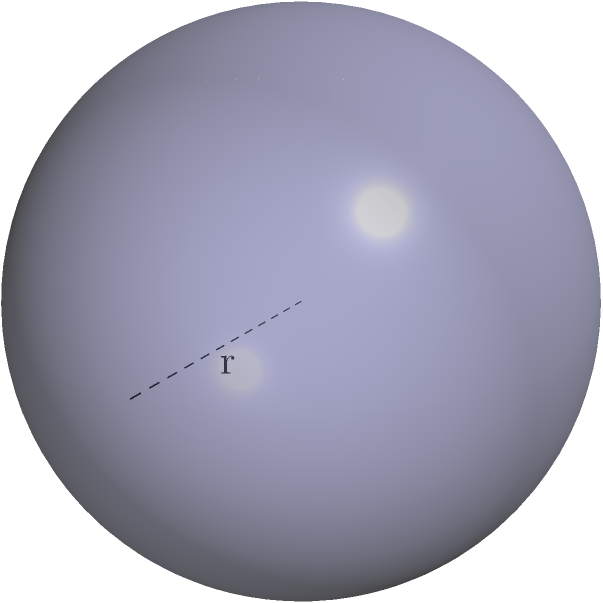In your XML integration project, you need to calculate the surface area of a spherical data structure. If the radius of this sphere is 2 units, what is its surface area? Express your answer in terms of $\pi$. To find the surface area of a sphere, we can follow these steps:

1. Recall the formula for the surface area of a sphere:
   $$ A = 4\pi r^2 $$
   where $A$ is the surface area and $r$ is the radius.

2. We are given that the radius $r = 2$ units.

3. Substitute $r = 2$ into the formula:
   $$ A = 4\pi (2)^2 $$

4. Simplify:
   $$ A = 4\pi \cdot 4 = 16\pi $$

5. Therefore, the surface area of the sphere is $16\pi$ square units.

This calculation could represent the total amount of data that can be stored on the surface of your spherical data structure in your XML integration project.
Answer: $16\pi$ square units 